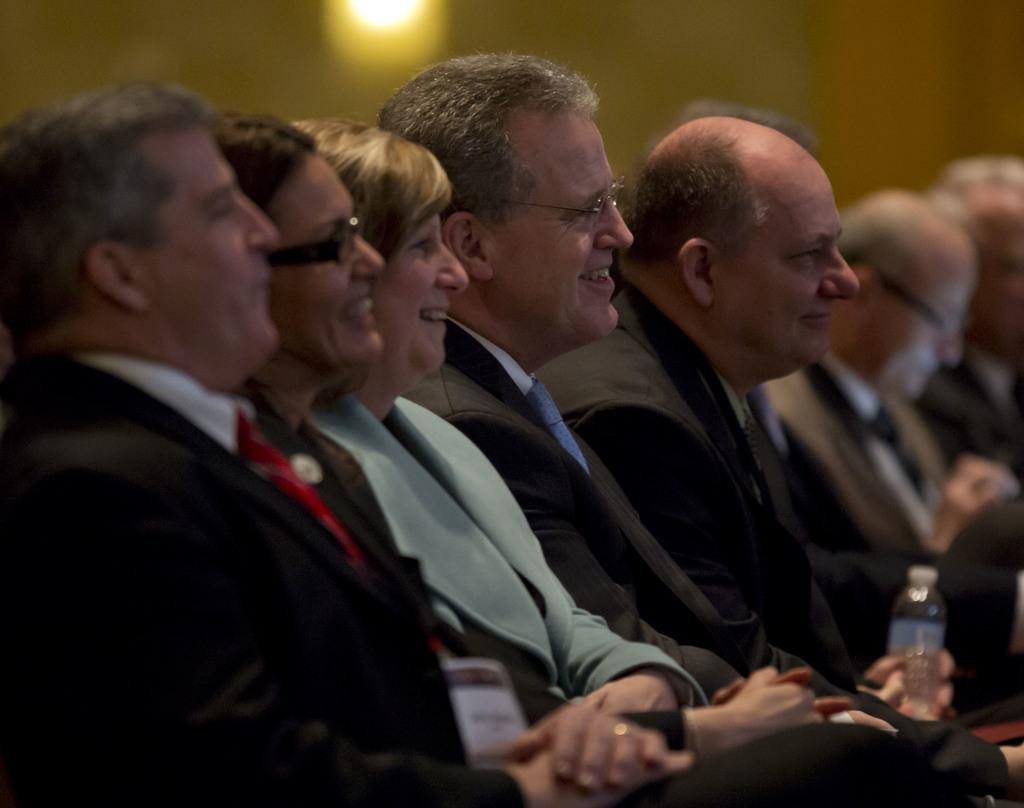What are the people in the image doing? The people in the image are sitting on chairs. Can you describe the gender of the people in the image? There are both men and a woman in the image. What is the general mood of the people in the image? Most of the people are smiling, which suggests a positive mood. How would you describe the background of the image? The background of the image is blurred. What type of linen is being used to cover the stomachs of the people in the image? There is no linen present in the image, nor is there any indication that the people's stomachs are covered. 